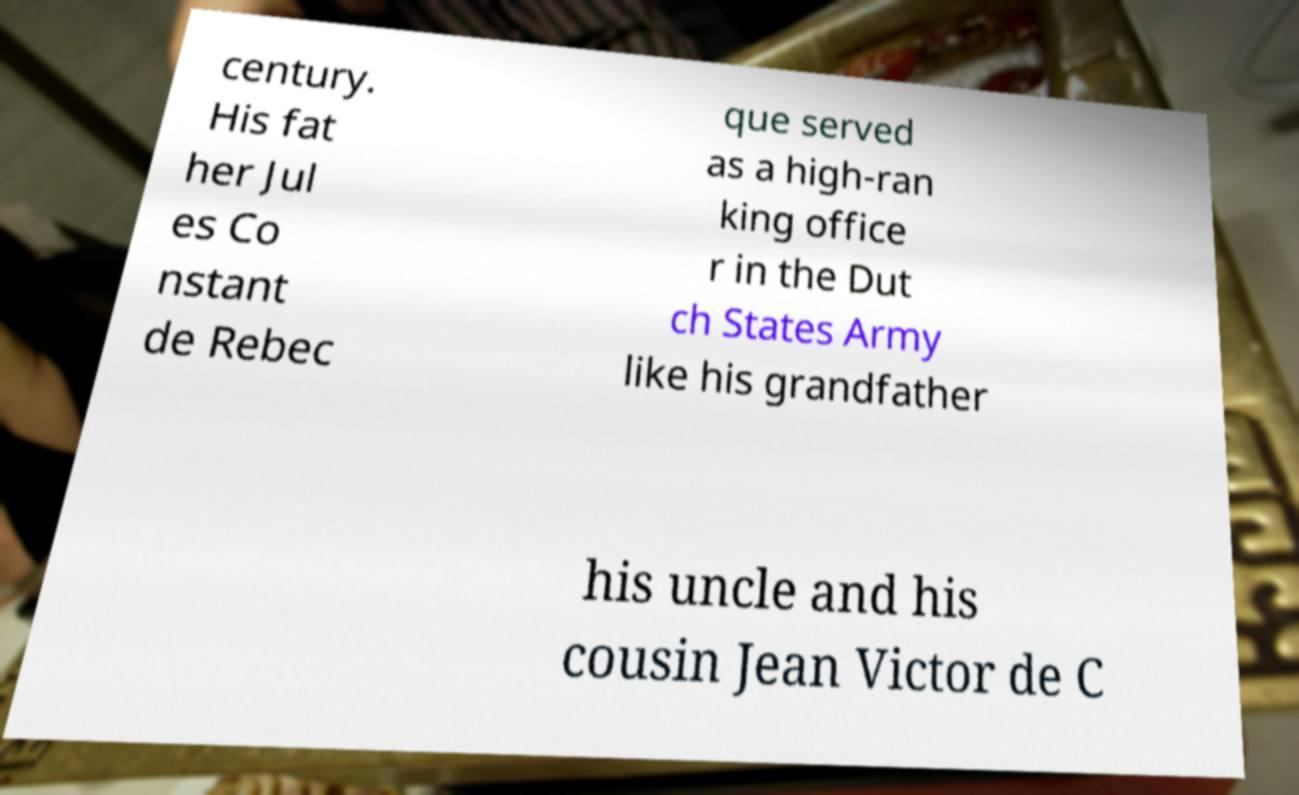What messages or text are displayed in this image? I need them in a readable, typed format. century. His fat her Jul es Co nstant de Rebec que served as a high-ran king office r in the Dut ch States Army like his grandfather his uncle and his cousin Jean Victor de C 